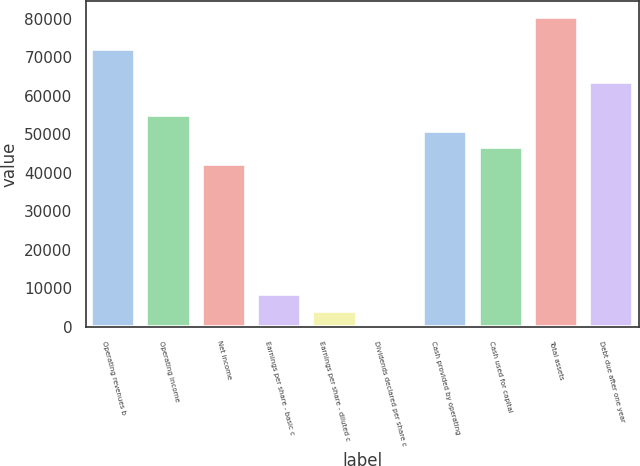Convert chart. <chart><loc_0><loc_0><loc_500><loc_500><bar_chart><fcel>Operating revenues b<fcel>Operating income<fcel>Net income<fcel>Earnings per share - basic c<fcel>Earnings per share - diluted c<fcel>Dividends declared per share c<fcel>Cash provided by operating<fcel>Cash used for capital<fcel>Total assets<fcel>Debt due after one year<nl><fcel>72096.2<fcel>55132.7<fcel>42410<fcel>8482.86<fcel>4241.97<fcel>1.08<fcel>50891.8<fcel>46650.9<fcel>80578<fcel>63614.4<nl></chart> 